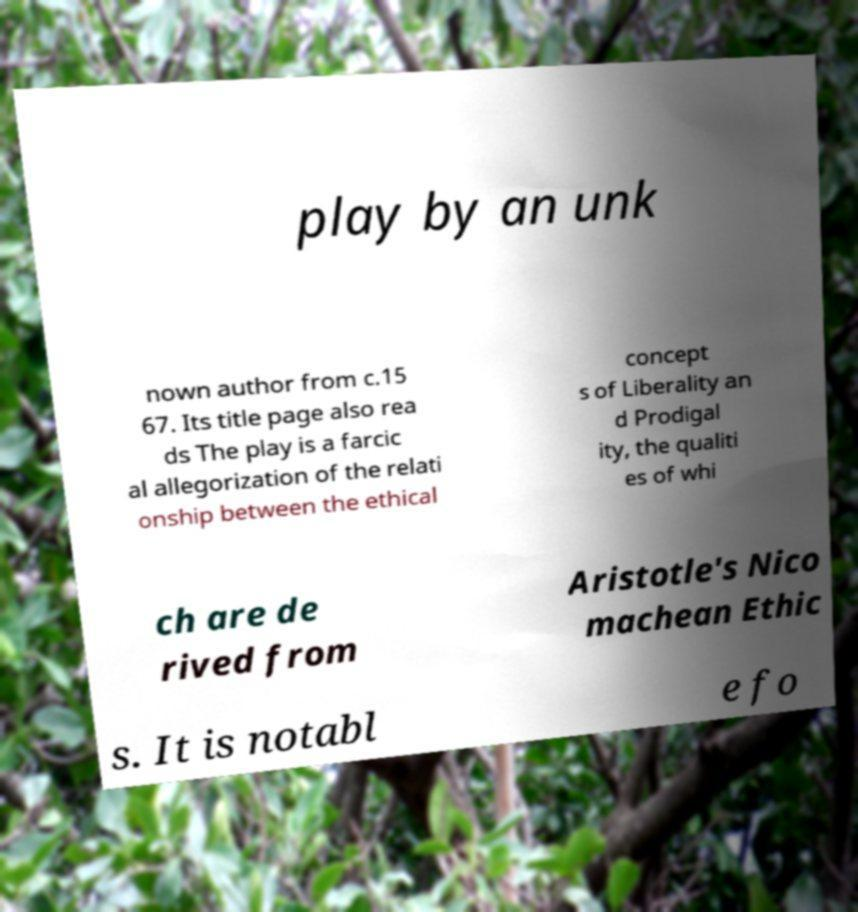What messages or text are displayed in this image? I need them in a readable, typed format. play by an unk nown author from c.15 67. Its title page also rea ds The play is a farcic al allegorization of the relati onship between the ethical concept s of Liberality an d Prodigal ity, the qualiti es of whi ch are de rived from Aristotle's Nico machean Ethic s. It is notabl e fo 